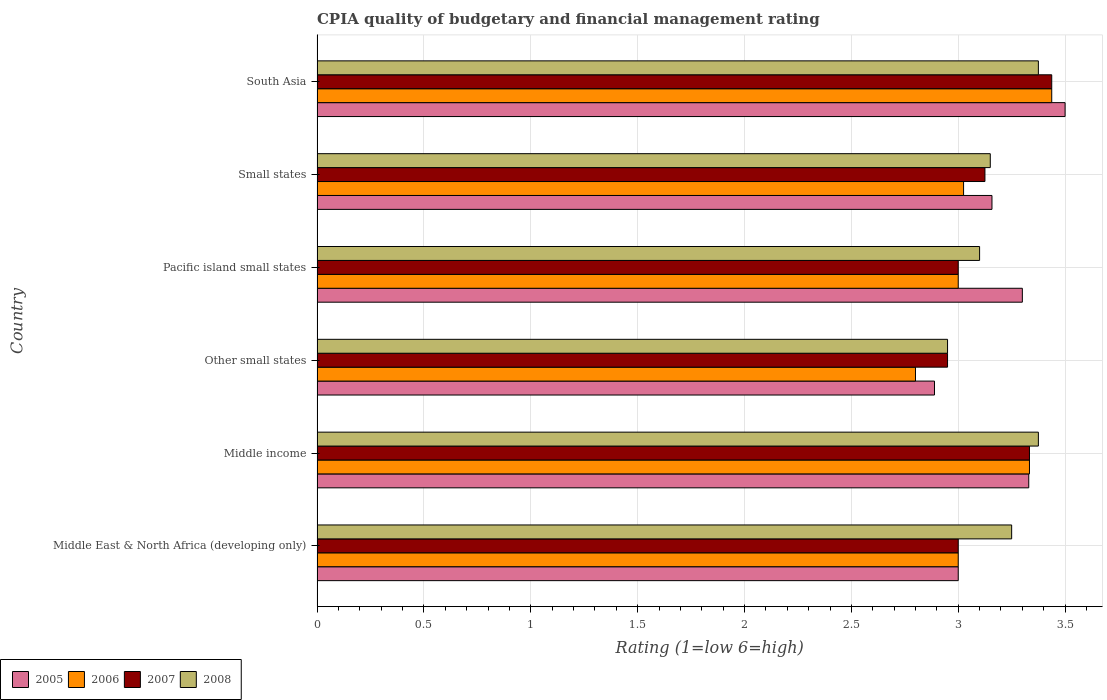How many groups of bars are there?
Provide a succinct answer. 6. Are the number of bars per tick equal to the number of legend labels?
Provide a short and direct response. Yes. Are the number of bars on each tick of the Y-axis equal?
Offer a very short reply. Yes. How many bars are there on the 3rd tick from the top?
Your response must be concise. 4. What is the label of the 2nd group of bars from the top?
Offer a terse response. Small states. What is the CPIA rating in 2006 in Middle income?
Provide a succinct answer. 3.33. Across all countries, what is the maximum CPIA rating in 2006?
Ensure brevity in your answer.  3.44. Across all countries, what is the minimum CPIA rating in 2005?
Offer a very short reply. 2.89. In which country was the CPIA rating in 2006 minimum?
Keep it short and to the point. Other small states. What is the total CPIA rating in 2008 in the graph?
Give a very brief answer. 19.2. What is the difference between the CPIA rating in 2005 in Other small states and that in Pacific island small states?
Your response must be concise. -0.41. What is the difference between the CPIA rating in 2008 in Other small states and the CPIA rating in 2005 in Middle East & North Africa (developing only)?
Your response must be concise. -0.05. What is the average CPIA rating in 2006 per country?
Your answer should be very brief. 3.1. What is the difference between the CPIA rating in 2005 and CPIA rating in 2007 in Middle income?
Provide a short and direct response. -0. In how many countries, is the CPIA rating in 2008 greater than 3.1 ?
Your answer should be very brief. 4. What is the ratio of the CPIA rating in 2005 in Middle East & North Africa (developing only) to that in Small states?
Make the answer very short. 0.95. Is the CPIA rating in 2006 in Other small states less than that in Small states?
Offer a very short reply. Yes. Is the difference between the CPIA rating in 2005 in Middle East & North Africa (developing only) and Small states greater than the difference between the CPIA rating in 2007 in Middle East & North Africa (developing only) and Small states?
Offer a very short reply. No. What is the difference between the highest and the second highest CPIA rating in 2006?
Provide a short and direct response. 0.1. What is the difference between the highest and the lowest CPIA rating in 2005?
Your answer should be compact. 0.61. In how many countries, is the CPIA rating in 2005 greater than the average CPIA rating in 2005 taken over all countries?
Your answer should be compact. 3. What does the 2nd bar from the bottom in Small states represents?
Your answer should be very brief. 2006. Is it the case that in every country, the sum of the CPIA rating in 2007 and CPIA rating in 2008 is greater than the CPIA rating in 2005?
Provide a short and direct response. Yes. How many bars are there?
Offer a terse response. 24. How many countries are there in the graph?
Ensure brevity in your answer.  6. How many legend labels are there?
Your answer should be very brief. 4. What is the title of the graph?
Offer a terse response. CPIA quality of budgetary and financial management rating. What is the Rating (1=low 6=high) in 2005 in Middle income?
Keep it short and to the point. 3.33. What is the Rating (1=low 6=high) of 2006 in Middle income?
Offer a very short reply. 3.33. What is the Rating (1=low 6=high) of 2007 in Middle income?
Your answer should be very brief. 3.33. What is the Rating (1=low 6=high) of 2008 in Middle income?
Ensure brevity in your answer.  3.38. What is the Rating (1=low 6=high) in 2005 in Other small states?
Your response must be concise. 2.89. What is the Rating (1=low 6=high) of 2006 in Other small states?
Ensure brevity in your answer.  2.8. What is the Rating (1=low 6=high) in 2007 in Other small states?
Make the answer very short. 2.95. What is the Rating (1=low 6=high) of 2008 in Other small states?
Your response must be concise. 2.95. What is the Rating (1=low 6=high) in 2006 in Pacific island small states?
Offer a terse response. 3. What is the Rating (1=low 6=high) in 2007 in Pacific island small states?
Make the answer very short. 3. What is the Rating (1=low 6=high) of 2008 in Pacific island small states?
Give a very brief answer. 3.1. What is the Rating (1=low 6=high) in 2005 in Small states?
Offer a very short reply. 3.16. What is the Rating (1=low 6=high) of 2006 in Small states?
Offer a terse response. 3.02. What is the Rating (1=low 6=high) of 2007 in Small states?
Make the answer very short. 3.12. What is the Rating (1=low 6=high) in 2008 in Small states?
Offer a very short reply. 3.15. What is the Rating (1=low 6=high) of 2005 in South Asia?
Your answer should be very brief. 3.5. What is the Rating (1=low 6=high) of 2006 in South Asia?
Give a very brief answer. 3.44. What is the Rating (1=low 6=high) of 2007 in South Asia?
Make the answer very short. 3.44. What is the Rating (1=low 6=high) in 2008 in South Asia?
Offer a very short reply. 3.38. Across all countries, what is the maximum Rating (1=low 6=high) of 2006?
Ensure brevity in your answer.  3.44. Across all countries, what is the maximum Rating (1=low 6=high) in 2007?
Give a very brief answer. 3.44. Across all countries, what is the maximum Rating (1=low 6=high) of 2008?
Provide a short and direct response. 3.38. Across all countries, what is the minimum Rating (1=low 6=high) in 2005?
Offer a terse response. 2.89. Across all countries, what is the minimum Rating (1=low 6=high) of 2007?
Your answer should be compact. 2.95. Across all countries, what is the minimum Rating (1=low 6=high) in 2008?
Provide a succinct answer. 2.95. What is the total Rating (1=low 6=high) of 2005 in the graph?
Ensure brevity in your answer.  19.18. What is the total Rating (1=low 6=high) of 2006 in the graph?
Ensure brevity in your answer.  18.6. What is the total Rating (1=low 6=high) in 2007 in the graph?
Your response must be concise. 18.85. What is the total Rating (1=low 6=high) of 2008 in the graph?
Your answer should be compact. 19.2. What is the difference between the Rating (1=low 6=high) of 2005 in Middle East & North Africa (developing only) and that in Middle income?
Your answer should be very brief. -0.33. What is the difference between the Rating (1=low 6=high) in 2008 in Middle East & North Africa (developing only) and that in Middle income?
Keep it short and to the point. -0.12. What is the difference between the Rating (1=low 6=high) in 2005 in Middle East & North Africa (developing only) and that in Other small states?
Keep it short and to the point. 0.11. What is the difference between the Rating (1=low 6=high) of 2006 in Middle East & North Africa (developing only) and that in Other small states?
Your response must be concise. 0.2. What is the difference between the Rating (1=low 6=high) in 2007 in Middle East & North Africa (developing only) and that in Other small states?
Provide a short and direct response. 0.05. What is the difference between the Rating (1=low 6=high) of 2005 in Middle East & North Africa (developing only) and that in Small states?
Give a very brief answer. -0.16. What is the difference between the Rating (1=low 6=high) in 2006 in Middle East & North Africa (developing only) and that in Small states?
Make the answer very short. -0.03. What is the difference between the Rating (1=low 6=high) of 2007 in Middle East & North Africa (developing only) and that in Small states?
Your response must be concise. -0.12. What is the difference between the Rating (1=low 6=high) of 2005 in Middle East & North Africa (developing only) and that in South Asia?
Make the answer very short. -0.5. What is the difference between the Rating (1=low 6=high) of 2006 in Middle East & North Africa (developing only) and that in South Asia?
Provide a short and direct response. -0.44. What is the difference between the Rating (1=low 6=high) of 2007 in Middle East & North Africa (developing only) and that in South Asia?
Make the answer very short. -0.44. What is the difference between the Rating (1=low 6=high) of 2008 in Middle East & North Africa (developing only) and that in South Asia?
Ensure brevity in your answer.  -0.12. What is the difference between the Rating (1=low 6=high) of 2005 in Middle income and that in Other small states?
Ensure brevity in your answer.  0.44. What is the difference between the Rating (1=low 6=high) in 2006 in Middle income and that in Other small states?
Offer a terse response. 0.53. What is the difference between the Rating (1=low 6=high) in 2007 in Middle income and that in Other small states?
Make the answer very short. 0.38. What is the difference between the Rating (1=low 6=high) of 2008 in Middle income and that in Other small states?
Your response must be concise. 0.42. What is the difference between the Rating (1=low 6=high) in 2007 in Middle income and that in Pacific island small states?
Ensure brevity in your answer.  0.33. What is the difference between the Rating (1=low 6=high) of 2008 in Middle income and that in Pacific island small states?
Provide a short and direct response. 0.28. What is the difference between the Rating (1=low 6=high) of 2005 in Middle income and that in Small states?
Offer a terse response. 0.17. What is the difference between the Rating (1=low 6=high) of 2006 in Middle income and that in Small states?
Your answer should be very brief. 0.31. What is the difference between the Rating (1=low 6=high) of 2007 in Middle income and that in Small states?
Your answer should be compact. 0.21. What is the difference between the Rating (1=low 6=high) of 2008 in Middle income and that in Small states?
Make the answer very short. 0.23. What is the difference between the Rating (1=low 6=high) of 2005 in Middle income and that in South Asia?
Your answer should be very brief. -0.17. What is the difference between the Rating (1=low 6=high) of 2006 in Middle income and that in South Asia?
Make the answer very short. -0.1. What is the difference between the Rating (1=low 6=high) in 2007 in Middle income and that in South Asia?
Make the answer very short. -0.1. What is the difference between the Rating (1=low 6=high) in 2008 in Middle income and that in South Asia?
Offer a terse response. 0. What is the difference between the Rating (1=low 6=high) of 2005 in Other small states and that in Pacific island small states?
Make the answer very short. -0.41. What is the difference between the Rating (1=low 6=high) in 2006 in Other small states and that in Pacific island small states?
Give a very brief answer. -0.2. What is the difference between the Rating (1=low 6=high) of 2005 in Other small states and that in Small states?
Keep it short and to the point. -0.27. What is the difference between the Rating (1=low 6=high) in 2006 in Other small states and that in Small states?
Provide a succinct answer. -0.23. What is the difference between the Rating (1=low 6=high) in 2007 in Other small states and that in Small states?
Provide a succinct answer. -0.17. What is the difference between the Rating (1=low 6=high) of 2005 in Other small states and that in South Asia?
Make the answer very short. -0.61. What is the difference between the Rating (1=low 6=high) of 2006 in Other small states and that in South Asia?
Offer a very short reply. -0.64. What is the difference between the Rating (1=low 6=high) in 2007 in Other small states and that in South Asia?
Your answer should be compact. -0.49. What is the difference between the Rating (1=low 6=high) in 2008 in Other small states and that in South Asia?
Provide a short and direct response. -0.42. What is the difference between the Rating (1=low 6=high) of 2005 in Pacific island small states and that in Small states?
Your response must be concise. 0.14. What is the difference between the Rating (1=low 6=high) in 2006 in Pacific island small states and that in Small states?
Provide a short and direct response. -0.03. What is the difference between the Rating (1=low 6=high) of 2007 in Pacific island small states and that in Small states?
Your answer should be compact. -0.12. What is the difference between the Rating (1=low 6=high) of 2006 in Pacific island small states and that in South Asia?
Provide a succinct answer. -0.44. What is the difference between the Rating (1=low 6=high) of 2007 in Pacific island small states and that in South Asia?
Ensure brevity in your answer.  -0.44. What is the difference between the Rating (1=low 6=high) in 2008 in Pacific island small states and that in South Asia?
Your answer should be very brief. -0.28. What is the difference between the Rating (1=low 6=high) in 2005 in Small states and that in South Asia?
Provide a short and direct response. -0.34. What is the difference between the Rating (1=low 6=high) in 2006 in Small states and that in South Asia?
Ensure brevity in your answer.  -0.41. What is the difference between the Rating (1=low 6=high) of 2007 in Small states and that in South Asia?
Provide a succinct answer. -0.31. What is the difference between the Rating (1=low 6=high) in 2008 in Small states and that in South Asia?
Ensure brevity in your answer.  -0.23. What is the difference between the Rating (1=low 6=high) in 2005 in Middle East & North Africa (developing only) and the Rating (1=low 6=high) in 2006 in Middle income?
Make the answer very short. -0.33. What is the difference between the Rating (1=low 6=high) of 2005 in Middle East & North Africa (developing only) and the Rating (1=low 6=high) of 2007 in Middle income?
Keep it short and to the point. -0.33. What is the difference between the Rating (1=low 6=high) of 2005 in Middle East & North Africa (developing only) and the Rating (1=low 6=high) of 2008 in Middle income?
Offer a terse response. -0.38. What is the difference between the Rating (1=low 6=high) of 2006 in Middle East & North Africa (developing only) and the Rating (1=low 6=high) of 2008 in Middle income?
Keep it short and to the point. -0.38. What is the difference between the Rating (1=low 6=high) in 2007 in Middle East & North Africa (developing only) and the Rating (1=low 6=high) in 2008 in Middle income?
Ensure brevity in your answer.  -0.38. What is the difference between the Rating (1=low 6=high) in 2005 in Middle East & North Africa (developing only) and the Rating (1=low 6=high) in 2008 in Other small states?
Your response must be concise. 0.05. What is the difference between the Rating (1=low 6=high) of 2006 in Middle East & North Africa (developing only) and the Rating (1=low 6=high) of 2008 in Other small states?
Keep it short and to the point. 0.05. What is the difference between the Rating (1=low 6=high) of 2007 in Middle East & North Africa (developing only) and the Rating (1=low 6=high) of 2008 in Other small states?
Your response must be concise. 0.05. What is the difference between the Rating (1=low 6=high) of 2005 in Middle East & North Africa (developing only) and the Rating (1=low 6=high) of 2007 in Pacific island small states?
Give a very brief answer. 0. What is the difference between the Rating (1=low 6=high) in 2005 in Middle East & North Africa (developing only) and the Rating (1=low 6=high) in 2008 in Pacific island small states?
Your answer should be compact. -0.1. What is the difference between the Rating (1=low 6=high) in 2006 in Middle East & North Africa (developing only) and the Rating (1=low 6=high) in 2008 in Pacific island small states?
Your answer should be very brief. -0.1. What is the difference between the Rating (1=low 6=high) of 2007 in Middle East & North Africa (developing only) and the Rating (1=low 6=high) of 2008 in Pacific island small states?
Offer a terse response. -0.1. What is the difference between the Rating (1=low 6=high) in 2005 in Middle East & North Africa (developing only) and the Rating (1=low 6=high) in 2006 in Small states?
Ensure brevity in your answer.  -0.03. What is the difference between the Rating (1=low 6=high) in 2005 in Middle East & North Africa (developing only) and the Rating (1=low 6=high) in 2007 in Small states?
Offer a very short reply. -0.12. What is the difference between the Rating (1=low 6=high) in 2005 in Middle East & North Africa (developing only) and the Rating (1=low 6=high) in 2008 in Small states?
Your response must be concise. -0.15. What is the difference between the Rating (1=low 6=high) of 2006 in Middle East & North Africa (developing only) and the Rating (1=low 6=high) of 2007 in Small states?
Make the answer very short. -0.12. What is the difference between the Rating (1=low 6=high) of 2006 in Middle East & North Africa (developing only) and the Rating (1=low 6=high) of 2008 in Small states?
Keep it short and to the point. -0.15. What is the difference between the Rating (1=low 6=high) of 2005 in Middle East & North Africa (developing only) and the Rating (1=low 6=high) of 2006 in South Asia?
Make the answer very short. -0.44. What is the difference between the Rating (1=low 6=high) of 2005 in Middle East & North Africa (developing only) and the Rating (1=low 6=high) of 2007 in South Asia?
Make the answer very short. -0.44. What is the difference between the Rating (1=low 6=high) in 2005 in Middle East & North Africa (developing only) and the Rating (1=low 6=high) in 2008 in South Asia?
Your answer should be compact. -0.38. What is the difference between the Rating (1=low 6=high) in 2006 in Middle East & North Africa (developing only) and the Rating (1=low 6=high) in 2007 in South Asia?
Offer a terse response. -0.44. What is the difference between the Rating (1=low 6=high) in 2006 in Middle East & North Africa (developing only) and the Rating (1=low 6=high) in 2008 in South Asia?
Your answer should be compact. -0.38. What is the difference between the Rating (1=low 6=high) in 2007 in Middle East & North Africa (developing only) and the Rating (1=low 6=high) in 2008 in South Asia?
Your answer should be very brief. -0.38. What is the difference between the Rating (1=low 6=high) in 2005 in Middle income and the Rating (1=low 6=high) in 2006 in Other small states?
Your answer should be compact. 0.53. What is the difference between the Rating (1=low 6=high) of 2005 in Middle income and the Rating (1=low 6=high) of 2007 in Other small states?
Your answer should be compact. 0.38. What is the difference between the Rating (1=low 6=high) in 2005 in Middle income and the Rating (1=low 6=high) in 2008 in Other small states?
Your answer should be very brief. 0.38. What is the difference between the Rating (1=low 6=high) in 2006 in Middle income and the Rating (1=low 6=high) in 2007 in Other small states?
Your response must be concise. 0.38. What is the difference between the Rating (1=low 6=high) of 2006 in Middle income and the Rating (1=low 6=high) of 2008 in Other small states?
Provide a short and direct response. 0.38. What is the difference between the Rating (1=low 6=high) of 2007 in Middle income and the Rating (1=low 6=high) of 2008 in Other small states?
Your answer should be very brief. 0.38. What is the difference between the Rating (1=low 6=high) of 2005 in Middle income and the Rating (1=low 6=high) of 2006 in Pacific island small states?
Your answer should be compact. 0.33. What is the difference between the Rating (1=low 6=high) of 2005 in Middle income and the Rating (1=low 6=high) of 2007 in Pacific island small states?
Your response must be concise. 0.33. What is the difference between the Rating (1=low 6=high) in 2005 in Middle income and the Rating (1=low 6=high) in 2008 in Pacific island small states?
Your answer should be compact. 0.23. What is the difference between the Rating (1=low 6=high) in 2006 in Middle income and the Rating (1=low 6=high) in 2007 in Pacific island small states?
Your answer should be very brief. 0.33. What is the difference between the Rating (1=low 6=high) of 2006 in Middle income and the Rating (1=low 6=high) of 2008 in Pacific island small states?
Give a very brief answer. 0.23. What is the difference between the Rating (1=low 6=high) of 2007 in Middle income and the Rating (1=low 6=high) of 2008 in Pacific island small states?
Make the answer very short. 0.23. What is the difference between the Rating (1=low 6=high) of 2005 in Middle income and the Rating (1=low 6=high) of 2006 in Small states?
Offer a terse response. 0.3. What is the difference between the Rating (1=low 6=high) of 2005 in Middle income and the Rating (1=low 6=high) of 2007 in Small states?
Provide a succinct answer. 0.2. What is the difference between the Rating (1=low 6=high) in 2005 in Middle income and the Rating (1=low 6=high) in 2008 in Small states?
Provide a short and direct response. 0.18. What is the difference between the Rating (1=low 6=high) in 2006 in Middle income and the Rating (1=low 6=high) in 2007 in Small states?
Provide a short and direct response. 0.21. What is the difference between the Rating (1=low 6=high) in 2006 in Middle income and the Rating (1=low 6=high) in 2008 in Small states?
Keep it short and to the point. 0.18. What is the difference between the Rating (1=low 6=high) in 2007 in Middle income and the Rating (1=low 6=high) in 2008 in Small states?
Ensure brevity in your answer.  0.18. What is the difference between the Rating (1=low 6=high) of 2005 in Middle income and the Rating (1=low 6=high) of 2006 in South Asia?
Keep it short and to the point. -0.11. What is the difference between the Rating (1=low 6=high) of 2005 in Middle income and the Rating (1=low 6=high) of 2007 in South Asia?
Keep it short and to the point. -0.11. What is the difference between the Rating (1=low 6=high) of 2005 in Middle income and the Rating (1=low 6=high) of 2008 in South Asia?
Make the answer very short. -0.04. What is the difference between the Rating (1=low 6=high) of 2006 in Middle income and the Rating (1=low 6=high) of 2007 in South Asia?
Keep it short and to the point. -0.1. What is the difference between the Rating (1=low 6=high) in 2006 in Middle income and the Rating (1=low 6=high) in 2008 in South Asia?
Provide a short and direct response. -0.04. What is the difference between the Rating (1=low 6=high) of 2007 in Middle income and the Rating (1=low 6=high) of 2008 in South Asia?
Your answer should be very brief. -0.04. What is the difference between the Rating (1=low 6=high) in 2005 in Other small states and the Rating (1=low 6=high) in 2006 in Pacific island small states?
Offer a very short reply. -0.11. What is the difference between the Rating (1=low 6=high) in 2005 in Other small states and the Rating (1=low 6=high) in 2007 in Pacific island small states?
Provide a succinct answer. -0.11. What is the difference between the Rating (1=low 6=high) of 2005 in Other small states and the Rating (1=low 6=high) of 2008 in Pacific island small states?
Your answer should be compact. -0.21. What is the difference between the Rating (1=low 6=high) in 2005 in Other small states and the Rating (1=low 6=high) in 2006 in Small states?
Offer a very short reply. -0.14. What is the difference between the Rating (1=low 6=high) of 2005 in Other small states and the Rating (1=low 6=high) of 2007 in Small states?
Keep it short and to the point. -0.24. What is the difference between the Rating (1=low 6=high) of 2005 in Other small states and the Rating (1=low 6=high) of 2008 in Small states?
Provide a short and direct response. -0.26. What is the difference between the Rating (1=low 6=high) of 2006 in Other small states and the Rating (1=low 6=high) of 2007 in Small states?
Provide a succinct answer. -0.33. What is the difference between the Rating (1=low 6=high) of 2006 in Other small states and the Rating (1=low 6=high) of 2008 in Small states?
Your answer should be very brief. -0.35. What is the difference between the Rating (1=low 6=high) of 2007 in Other small states and the Rating (1=low 6=high) of 2008 in Small states?
Offer a very short reply. -0.2. What is the difference between the Rating (1=low 6=high) in 2005 in Other small states and the Rating (1=low 6=high) in 2006 in South Asia?
Your answer should be compact. -0.55. What is the difference between the Rating (1=low 6=high) in 2005 in Other small states and the Rating (1=low 6=high) in 2007 in South Asia?
Keep it short and to the point. -0.55. What is the difference between the Rating (1=low 6=high) of 2005 in Other small states and the Rating (1=low 6=high) of 2008 in South Asia?
Ensure brevity in your answer.  -0.49. What is the difference between the Rating (1=low 6=high) of 2006 in Other small states and the Rating (1=low 6=high) of 2007 in South Asia?
Offer a terse response. -0.64. What is the difference between the Rating (1=low 6=high) of 2006 in Other small states and the Rating (1=low 6=high) of 2008 in South Asia?
Ensure brevity in your answer.  -0.57. What is the difference between the Rating (1=low 6=high) of 2007 in Other small states and the Rating (1=low 6=high) of 2008 in South Asia?
Your answer should be compact. -0.42. What is the difference between the Rating (1=low 6=high) of 2005 in Pacific island small states and the Rating (1=low 6=high) of 2006 in Small states?
Give a very brief answer. 0.28. What is the difference between the Rating (1=low 6=high) of 2005 in Pacific island small states and the Rating (1=low 6=high) of 2007 in Small states?
Make the answer very short. 0.17. What is the difference between the Rating (1=low 6=high) in 2006 in Pacific island small states and the Rating (1=low 6=high) in 2007 in Small states?
Provide a succinct answer. -0.12. What is the difference between the Rating (1=low 6=high) of 2006 in Pacific island small states and the Rating (1=low 6=high) of 2008 in Small states?
Make the answer very short. -0.15. What is the difference between the Rating (1=low 6=high) of 2007 in Pacific island small states and the Rating (1=low 6=high) of 2008 in Small states?
Offer a terse response. -0.15. What is the difference between the Rating (1=low 6=high) in 2005 in Pacific island small states and the Rating (1=low 6=high) in 2006 in South Asia?
Your response must be concise. -0.14. What is the difference between the Rating (1=low 6=high) of 2005 in Pacific island small states and the Rating (1=low 6=high) of 2007 in South Asia?
Provide a succinct answer. -0.14. What is the difference between the Rating (1=low 6=high) in 2005 in Pacific island small states and the Rating (1=low 6=high) in 2008 in South Asia?
Make the answer very short. -0.07. What is the difference between the Rating (1=low 6=high) in 2006 in Pacific island small states and the Rating (1=low 6=high) in 2007 in South Asia?
Give a very brief answer. -0.44. What is the difference between the Rating (1=low 6=high) of 2006 in Pacific island small states and the Rating (1=low 6=high) of 2008 in South Asia?
Keep it short and to the point. -0.38. What is the difference between the Rating (1=low 6=high) of 2007 in Pacific island small states and the Rating (1=low 6=high) of 2008 in South Asia?
Give a very brief answer. -0.38. What is the difference between the Rating (1=low 6=high) of 2005 in Small states and the Rating (1=low 6=high) of 2006 in South Asia?
Your answer should be compact. -0.28. What is the difference between the Rating (1=low 6=high) in 2005 in Small states and the Rating (1=low 6=high) in 2007 in South Asia?
Offer a very short reply. -0.28. What is the difference between the Rating (1=low 6=high) in 2005 in Small states and the Rating (1=low 6=high) in 2008 in South Asia?
Provide a short and direct response. -0.22. What is the difference between the Rating (1=low 6=high) in 2006 in Small states and the Rating (1=low 6=high) in 2007 in South Asia?
Ensure brevity in your answer.  -0.41. What is the difference between the Rating (1=low 6=high) of 2006 in Small states and the Rating (1=low 6=high) of 2008 in South Asia?
Offer a very short reply. -0.35. What is the difference between the Rating (1=low 6=high) in 2007 in Small states and the Rating (1=low 6=high) in 2008 in South Asia?
Make the answer very short. -0.25. What is the average Rating (1=low 6=high) in 2005 per country?
Offer a terse response. 3.2. What is the average Rating (1=low 6=high) in 2006 per country?
Ensure brevity in your answer.  3.1. What is the average Rating (1=low 6=high) in 2007 per country?
Provide a short and direct response. 3.14. What is the difference between the Rating (1=low 6=high) in 2005 and Rating (1=low 6=high) in 2007 in Middle East & North Africa (developing only)?
Give a very brief answer. 0. What is the difference between the Rating (1=low 6=high) in 2005 and Rating (1=low 6=high) in 2008 in Middle East & North Africa (developing only)?
Offer a very short reply. -0.25. What is the difference between the Rating (1=low 6=high) in 2006 and Rating (1=low 6=high) in 2007 in Middle East & North Africa (developing only)?
Give a very brief answer. 0. What is the difference between the Rating (1=low 6=high) in 2005 and Rating (1=low 6=high) in 2006 in Middle income?
Offer a very short reply. -0. What is the difference between the Rating (1=low 6=high) in 2005 and Rating (1=low 6=high) in 2007 in Middle income?
Provide a succinct answer. -0. What is the difference between the Rating (1=low 6=high) in 2005 and Rating (1=low 6=high) in 2008 in Middle income?
Your response must be concise. -0.04. What is the difference between the Rating (1=low 6=high) in 2006 and Rating (1=low 6=high) in 2008 in Middle income?
Make the answer very short. -0.04. What is the difference between the Rating (1=low 6=high) in 2007 and Rating (1=low 6=high) in 2008 in Middle income?
Offer a terse response. -0.04. What is the difference between the Rating (1=low 6=high) in 2005 and Rating (1=low 6=high) in 2006 in Other small states?
Your answer should be compact. 0.09. What is the difference between the Rating (1=low 6=high) of 2005 and Rating (1=low 6=high) of 2007 in Other small states?
Provide a short and direct response. -0.06. What is the difference between the Rating (1=low 6=high) in 2005 and Rating (1=low 6=high) in 2008 in Other small states?
Offer a very short reply. -0.06. What is the difference between the Rating (1=low 6=high) of 2007 and Rating (1=low 6=high) of 2008 in Other small states?
Make the answer very short. 0. What is the difference between the Rating (1=low 6=high) in 2005 and Rating (1=low 6=high) in 2006 in Pacific island small states?
Your answer should be very brief. 0.3. What is the difference between the Rating (1=low 6=high) of 2005 and Rating (1=low 6=high) of 2007 in Pacific island small states?
Offer a terse response. 0.3. What is the difference between the Rating (1=low 6=high) in 2005 and Rating (1=low 6=high) in 2008 in Pacific island small states?
Offer a very short reply. 0.2. What is the difference between the Rating (1=low 6=high) in 2006 and Rating (1=low 6=high) in 2007 in Pacific island small states?
Offer a very short reply. 0. What is the difference between the Rating (1=low 6=high) in 2005 and Rating (1=low 6=high) in 2006 in Small states?
Offer a very short reply. 0.13. What is the difference between the Rating (1=low 6=high) in 2005 and Rating (1=low 6=high) in 2007 in Small states?
Your answer should be compact. 0.03. What is the difference between the Rating (1=low 6=high) in 2005 and Rating (1=low 6=high) in 2008 in Small states?
Offer a very short reply. 0.01. What is the difference between the Rating (1=low 6=high) of 2006 and Rating (1=low 6=high) of 2007 in Small states?
Your answer should be very brief. -0.1. What is the difference between the Rating (1=low 6=high) of 2006 and Rating (1=low 6=high) of 2008 in Small states?
Give a very brief answer. -0.12. What is the difference between the Rating (1=low 6=high) in 2007 and Rating (1=low 6=high) in 2008 in Small states?
Offer a terse response. -0.03. What is the difference between the Rating (1=low 6=high) in 2005 and Rating (1=low 6=high) in 2006 in South Asia?
Offer a very short reply. 0.06. What is the difference between the Rating (1=low 6=high) in 2005 and Rating (1=low 6=high) in 2007 in South Asia?
Keep it short and to the point. 0.06. What is the difference between the Rating (1=low 6=high) in 2005 and Rating (1=low 6=high) in 2008 in South Asia?
Offer a very short reply. 0.12. What is the difference between the Rating (1=low 6=high) of 2006 and Rating (1=low 6=high) of 2007 in South Asia?
Your response must be concise. 0. What is the difference between the Rating (1=low 6=high) in 2006 and Rating (1=low 6=high) in 2008 in South Asia?
Your answer should be compact. 0.06. What is the difference between the Rating (1=low 6=high) of 2007 and Rating (1=low 6=high) of 2008 in South Asia?
Provide a succinct answer. 0.06. What is the ratio of the Rating (1=low 6=high) of 2005 in Middle East & North Africa (developing only) to that in Middle income?
Make the answer very short. 0.9. What is the ratio of the Rating (1=low 6=high) of 2006 in Middle East & North Africa (developing only) to that in Middle income?
Offer a terse response. 0.9. What is the ratio of the Rating (1=low 6=high) in 2007 in Middle East & North Africa (developing only) to that in Middle income?
Offer a terse response. 0.9. What is the ratio of the Rating (1=low 6=high) in 2006 in Middle East & North Africa (developing only) to that in Other small states?
Give a very brief answer. 1.07. What is the ratio of the Rating (1=low 6=high) in 2007 in Middle East & North Africa (developing only) to that in Other small states?
Your response must be concise. 1.02. What is the ratio of the Rating (1=low 6=high) in 2008 in Middle East & North Africa (developing only) to that in Other small states?
Offer a terse response. 1.1. What is the ratio of the Rating (1=low 6=high) in 2005 in Middle East & North Africa (developing only) to that in Pacific island small states?
Offer a very short reply. 0.91. What is the ratio of the Rating (1=low 6=high) of 2008 in Middle East & North Africa (developing only) to that in Pacific island small states?
Your response must be concise. 1.05. What is the ratio of the Rating (1=low 6=high) in 2005 in Middle East & North Africa (developing only) to that in Small states?
Offer a very short reply. 0.95. What is the ratio of the Rating (1=low 6=high) in 2006 in Middle East & North Africa (developing only) to that in Small states?
Provide a succinct answer. 0.99. What is the ratio of the Rating (1=low 6=high) of 2007 in Middle East & North Africa (developing only) to that in Small states?
Your answer should be compact. 0.96. What is the ratio of the Rating (1=low 6=high) of 2008 in Middle East & North Africa (developing only) to that in Small states?
Give a very brief answer. 1.03. What is the ratio of the Rating (1=low 6=high) of 2006 in Middle East & North Africa (developing only) to that in South Asia?
Keep it short and to the point. 0.87. What is the ratio of the Rating (1=low 6=high) in 2007 in Middle East & North Africa (developing only) to that in South Asia?
Make the answer very short. 0.87. What is the ratio of the Rating (1=low 6=high) of 2005 in Middle income to that in Other small states?
Your answer should be compact. 1.15. What is the ratio of the Rating (1=low 6=high) in 2006 in Middle income to that in Other small states?
Provide a succinct answer. 1.19. What is the ratio of the Rating (1=low 6=high) in 2007 in Middle income to that in Other small states?
Your answer should be very brief. 1.13. What is the ratio of the Rating (1=low 6=high) of 2008 in Middle income to that in Other small states?
Your response must be concise. 1.14. What is the ratio of the Rating (1=low 6=high) in 2005 in Middle income to that in Pacific island small states?
Give a very brief answer. 1.01. What is the ratio of the Rating (1=low 6=high) of 2007 in Middle income to that in Pacific island small states?
Your response must be concise. 1.11. What is the ratio of the Rating (1=low 6=high) of 2008 in Middle income to that in Pacific island small states?
Provide a short and direct response. 1.09. What is the ratio of the Rating (1=low 6=high) of 2005 in Middle income to that in Small states?
Your answer should be very brief. 1.05. What is the ratio of the Rating (1=low 6=high) of 2006 in Middle income to that in Small states?
Your response must be concise. 1.1. What is the ratio of the Rating (1=low 6=high) of 2007 in Middle income to that in Small states?
Offer a very short reply. 1.07. What is the ratio of the Rating (1=low 6=high) of 2008 in Middle income to that in Small states?
Provide a short and direct response. 1.07. What is the ratio of the Rating (1=low 6=high) in 2005 in Middle income to that in South Asia?
Offer a very short reply. 0.95. What is the ratio of the Rating (1=low 6=high) of 2006 in Middle income to that in South Asia?
Give a very brief answer. 0.97. What is the ratio of the Rating (1=low 6=high) in 2007 in Middle income to that in South Asia?
Give a very brief answer. 0.97. What is the ratio of the Rating (1=low 6=high) in 2008 in Middle income to that in South Asia?
Provide a short and direct response. 1. What is the ratio of the Rating (1=low 6=high) in 2005 in Other small states to that in Pacific island small states?
Keep it short and to the point. 0.88. What is the ratio of the Rating (1=low 6=high) of 2007 in Other small states to that in Pacific island small states?
Make the answer very short. 0.98. What is the ratio of the Rating (1=low 6=high) of 2008 in Other small states to that in Pacific island small states?
Offer a very short reply. 0.95. What is the ratio of the Rating (1=low 6=high) of 2005 in Other small states to that in Small states?
Make the answer very short. 0.91. What is the ratio of the Rating (1=low 6=high) in 2006 in Other small states to that in Small states?
Offer a terse response. 0.93. What is the ratio of the Rating (1=low 6=high) in 2007 in Other small states to that in Small states?
Your response must be concise. 0.94. What is the ratio of the Rating (1=low 6=high) of 2008 in Other small states to that in Small states?
Your answer should be compact. 0.94. What is the ratio of the Rating (1=low 6=high) in 2005 in Other small states to that in South Asia?
Give a very brief answer. 0.83. What is the ratio of the Rating (1=low 6=high) of 2006 in Other small states to that in South Asia?
Your response must be concise. 0.81. What is the ratio of the Rating (1=low 6=high) of 2007 in Other small states to that in South Asia?
Ensure brevity in your answer.  0.86. What is the ratio of the Rating (1=low 6=high) of 2008 in Other small states to that in South Asia?
Provide a succinct answer. 0.87. What is the ratio of the Rating (1=low 6=high) in 2005 in Pacific island small states to that in Small states?
Provide a short and direct response. 1.04. What is the ratio of the Rating (1=low 6=high) of 2007 in Pacific island small states to that in Small states?
Your answer should be compact. 0.96. What is the ratio of the Rating (1=low 6=high) of 2008 in Pacific island small states to that in Small states?
Give a very brief answer. 0.98. What is the ratio of the Rating (1=low 6=high) in 2005 in Pacific island small states to that in South Asia?
Offer a very short reply. 0.94. What is the ratio of the Rating (1=low 6=high) of 2006 in Pacific island small states to that in South Asia?
Give a very brief answer. 0.87. What is the ratio of the Rating (1=low 6=high) in 2007 in Pacific island small states to that in South Asia?
Keep it short and to the point. 0.87. What is the ratio of the Rating (1=low 6=high) in 2008 in Pacific island small states to that in South Asia?
Provide a succinct answer. 0.92. What is the ratio of the Rating (1=low 6=high) of 2005 in Small states to that in South Asia?
Give a very brief answer. 0.9. What is the ratio of the Rating (1=low 6=high) of 2007 in Small states to that in South Asia?
Provide a short and direct response. 0.91. What is the difference between the highest and the second highest Rating (1=low 6=high) of 2005?
Your response must be concise. 0.17. What is the difference between the highest and the second highest Rating (1=low 6=high) of 2006?
Make the answer very short. 0.1. What is the difference between the highest and the second highest Rating (1=low 6=high) of 2007?
Your answer should be compact. 0.1. What is the difference between the highest and the lowest Rating (1=low 6=high) of 2005?
Offer a terse response. 0.61. What is the difference between the highest and the lowest Rating (1=low 6=high) of 2006?
Keep it short and to the point. 0.64. What is the difference between the highest and the lowest Rating (1=low 6=high) of 2007?
Offer a terse response. 0.49. What is the difference between the highest and the lowest Rating (1=low 6=high) in 2008?
Offer a very short reply. 0.42. 